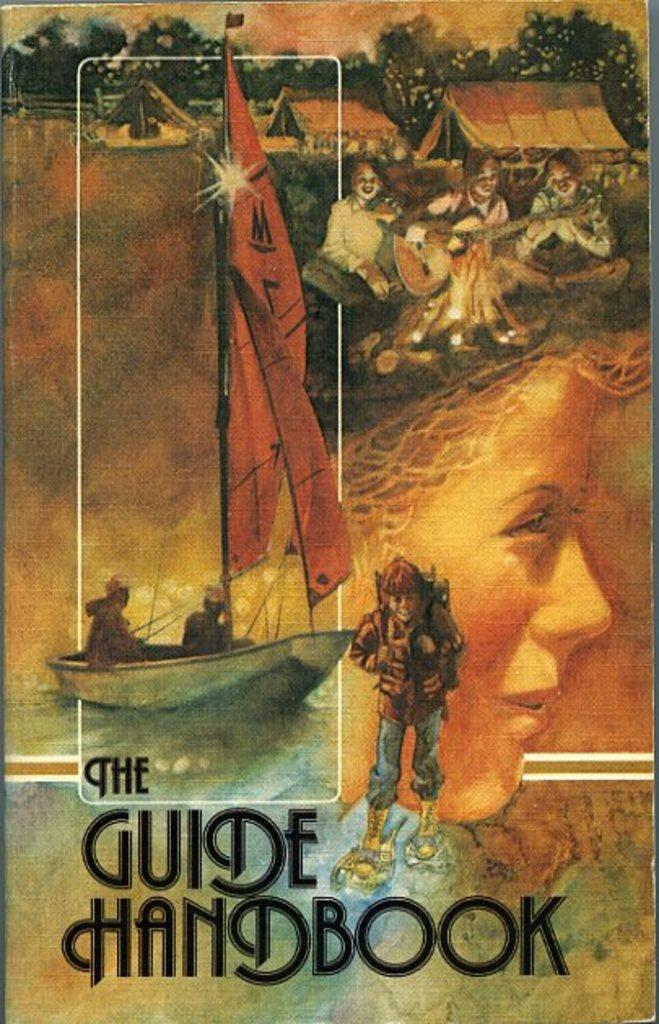What is depicted on the poster in the image? The poster contains people, houses, trees, and a boat. What else can be found on the poster besides the images? There are words on the poster. What texture can be felt on the poster? The texture of the poster cannot be determined from the image, as it is a two-dimensional representation. 